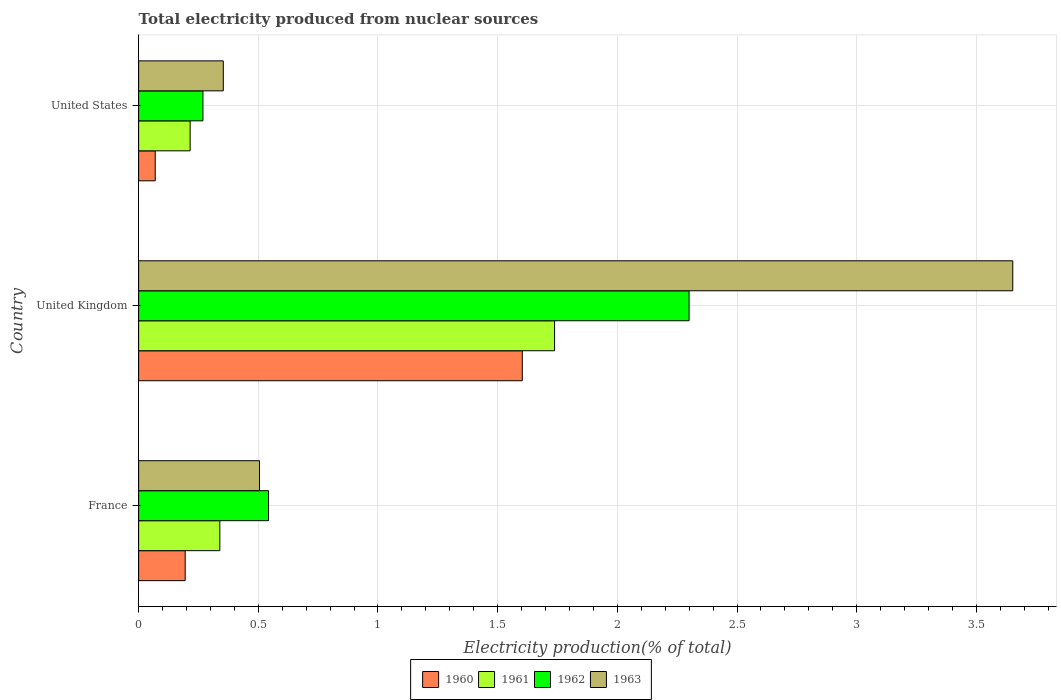How many different coloured bars are there?
Make the answer very short. 4. How many groups of bars are there?
Provide a short and direct response. 3. How many bars are there on the 3rd tick from the top?
Keep it short and to the point. 4. What is the label of the 2nd group of bars from the top?
Provide a succinct answer. United Kingdom. In how many cases, is the number of bars for a given country not equal to the number of legend labels?
Offer a very short reply. 0. What is the total electricity produced in 1962 in United States?
Offer a terse response. 0.27. Across all countries, what is the maximum total electricity produced in 1961?
Provide a short and direct response. 1.74. Across all countries, what is the minimum total electricity produced in 1962?
Your response must be concise. 0.27. What is the total total electricity produced in 1962 in the graph?
Your answer should be compact. 3.11. What is the difference between the total electricity produced in 1963 in France and that in United States?
Offer a terse response. 0.15. What is the difference between the total electricity produced in 1963 in United States and the total electricity produced in 1960 in United Kingdom?
Ensure brevity in your answer.  -1.25. What is the average total electricity produced in 1961 per country?
Keep it short and to the point. 0.76. What is the difference between the total electricity produced in 1962 and total electricity produced in 1960 in United States?
Make the answer very short. 0.2. In how many countries, is the total electricity produced in 1960 greater than 2.2 %?
Your answer should be compact. 0. What is the ratio of the total electricity produced in 1962 in United Kingdom to that in United States?
Your response must be concise. 8.56. Is the difference between the total electricity produced in 1962 in France and United States greater than the difference between the total electricity produced in 1960 in France and United States?
Your response must be concise. Yes. What is the difference between the highest and the second highest total electricity produced in 1962?
Your answer should be very brief. 1.76. What is the difference between the highest and the lowest total electricity produced in 1961?
Keep it short and to the point. 1.52. Is it the case that in every country, the sum of the total electricity produced in 1963 and total electricity produced in 1961 is greater than the sum of total electricity produced in 1960 and total electricity produced in 1962?
Offer a terse response. Yes. What does the 4th bar from the top in France represents?
Your response must be concise. 1960. Is it the case that in every country, the sum of the total electricity produced in 1961 and total electricity produced in 1963 is greater than the total electricity produced in 1960?
Your response must be concise. Yes. How many bars are there?
Offer a very short reply. 12. What is the difference between two consecutive major ticks on the X-axis?
Offer a terse response. 0.5. Does the graph contain any zero values?
Your answer should be compact. No. Does the graph contain grids?
Provide a succinct answer. Yes. How are the legend labels stacked?
Your answer should be compact. Horizontal. What is the title of the graph?
Your response must be concise. Total electricity produced from nuclear sources. Does "2001" appear as one of the legend labels in the graph?
Provide a succinct answer. No. What is the label or title of the X-axis?
Give a very brief answer. Electricity production(% of total). What is the label or title of the Y-axis?
Make the answer very short. Country. What is the Electricity production(% of total) in 1960 in France?
Offer a very short reply. 0.19. What is the Electricity production(% of total) of 1961 in France?
Your response must be concise. 0.34. What is the Electricity production(% of total) in 1962 in France?
Ensure brevity in your answer.  0.54. What is the Electricity production(% of total) in 1963 in France?
Provide a succinct answer. 0.51. What is the Electricity production(% of total) of 1960 in United Kingdom?
Your answer should be compact. 1.6. What is the Electricity production(% of total) of 1961 in United Kingdom?
Give a very brief answer. 1.74. What is the Electricity production(% of total) of 1962 in United Kingdom?
Make the answer very short. 2.3. What is the Electricity production(% of total) of 1963 in United Kingdom?
Give a very brief answer. 3.65. What is the Electricity production(% of total) in 1960 in United States?
Provide a short and direct response. 0.07. What is the Electricity production(% of total) of 1961 in United States?
Offer a terse response. 0.22. What is the Electricity production(% of total) in 1962 in United States?
Offer a very short reply. 0.27. What is the Electricity production(% of total) of 1963 in United States?
Provide a succinct answer. 0.35. Across all countries, what is the maximum Electricity production(% of total) in 1960?
Your answer should be compact. 1.6. Across all countries, what is the maximum Electricity production(% of total) in 1961?
Your response must be concise. 1.74. Across all countries, what is the maximum Electricity production(% of total) in 1962?
Ensure brevity in your answer.  2.3. Across all countries, what is the maximum Electricity production(% of total) of 1963?
Give a very brief answer. 3.65. Across all countries, what is the minimum Electricity production(% of total) of 1960?
Provide a succinct answer. 0.07. Across all countries, what is the minimum Electricity production(% of total) in 1961?
Make the answer very short. 0.22. Across all countries, what is the minimum Electricity production(% of total) in 1962?
Offer a terse response. 0.27. Across all countries, what is the minimum Electricity production(% of total) in 1963?
Keep it short and to the point. 0.35. What is the total Electricity production(% of total) of 1960 in the graph?
Provide a short and direct response. 1.87. What is the total Electricity production(% of total) of 1961 in the graph?
Provide a short and direct response. 2.29. What is the total Electricity production(% of total) in 1962 in the graph?
Make the answer very short. 3.11. What is the total Electricity production(% of total) of 1963 in the graph?
Provide a succinct answer. 4.51. What is the difference between the Electricity production(% of total) in 1960 in France and that in United Kingdom?
Your response must be concise. -1.41. What is the difference between the Electricity production(% of total) in 1961 in France and that in United Kingdom?
Give a very brief answer. -1.4. What is the difference between the Electricity production(% of total) in 1962 in France and that in United Kingdom?
Keep it short and to the point. -1.76. What is the difference between the Electricity production(% of total) of 1963 in France and that in United Kingdom?
Offer a very short reply. -3.15. What is the difference between the Electricity production(% of total) in 1960 in France and that in United States?
Make the answer very short. 0.13. What is the difference between the Electricity production(% of total) in 1961 in France and that in United States?
Your response must be concise. 0.12. What is the difference between the Electricity production(% of total) of 1962 in France and that in United States?
Your answer should be very brief. 0.27. What is the difference between the Electricity production(% of total) of 1963 in France and that in United States?
Offer a terse response. 0.15. What is the difference between the Electricity production(% of total) of 1960 in United Kingdom and that in United States?
Offer a very short reply. 1.53. What is the difference between the Electricity production(% of total) in 1961 in United Kingdom and that in United States?
Your response must be concise. 1.52. What is the difference between the Electricity production(% of total) in 1962 in United Kingdom and that in United States?
Provide a succinct answer. 2.03. What is the difference between the Electricity production(% of total) of 1963 in United Kingdom and that in United States?
Make the answer very short. 3.3. What is the difference between the Electricity production(% of total) of 1960 in France and the Electricity production(% of total) of 1961 in United Kingdom?
Your answer should be very brief. -1.54. What is the difference between the Electricity production(% of total) of 1960 in France and the Electricity production(% of total) of 1962 in United Kingdom?
Provide a short and direct response. -2.11. What is the difference between the Electricity production(% of total) of 1960 in France and the Electricity production(% of total) of 1963 in United Kingdom?
Provide a short and direct response. -3.46. What is the difference between the Electricity production(% of total) of 1961 in France and the Electricity production(% of total) of 1962 in United Kingdom?
Offer a terse response. -1.96. What is the difference between the Electricity production(% of total) of 1961 in France and the Electricity production(% of total) of 1963 in United Kingdom?
Make the answer very short. -3.31. What is the difference between the Electricity production(% of total) of 1962 in France and the Electricity production(% of total) of 1963 in United Kingdom?
Provide a succinct answer. -3.11. What is the difference between the Electricity production(% of total) in 1960 in France and the Electricity production(% of total) in 1961 in United States?
Your answer should be compact. -0.02. What is the difference between the Electricity production(% of total) of 1960 in France and the Electricity production(% of total) of 1962 in United States?
Provide a short and direct response. -0.07. What is the difference between the Electricity production(% of total) in 1960 in France and the Electricity production(% of total) in 1963 in United States?
Offer a terse response. -0.16. What is the difference between the Electricity production(% of total) of 1961 in France and the Electricity production(% of total) of 1962 in United States?
Your answer should be compact. 0.07. What is the difference between the Electricity production(% of total) of 1961 in France and the Electricity production(% of total) of 1963 in United States?
Offer a terse response. -0.01. What is the difference between the Electricity production(% of total) in 1962 in France and the Electricity production(% of total) in 1963 in United States?
Offer a very short reply. 0.19. What is the difference between the Electricity production(% of total) in 1960 in United Kingdom and the Electricity production(% of total) in 1961 in United States?
Provide a short and direct response. 1.39. What is the difference between the Electricity production(% of total) of 1960 in United Kingdom and the Electricity production(% of total) of 1962 in United States?
Offer a terse response. 1.33. What is the difference between the Electricity production(% of total) in 1960 in United Kingdom and the Electricity production(% of total) in 1963 in United States?
Your answer should be very brief. 1.25. What is the difference between the Electricity production(% of total) in 1961 in United Kingdom and the Electricity production(% of total) in 1962 in United States?
Your response must be concise. 1.47. What is the difference between the Electricity production(% of total) in 1961 in United Kingdom and the Electricity production(% of total) in 1963 in United States?
Offer a very short reply. 1.38. What is the difference between the Electricity production(% of total) of 1962 in United Kingdom and the Electricity production(% of total) of 1963 in United States?
Provide a short and direct response. 1.95. What is the average Electricity production(% of total) of 1960 per country?
Offer a very short reply. 0.62. What is the average Electricity production(% of total) in 1961 per country?
Make the answer very short. 0.76. What is the average Electricity production(% of total) in 1963 per country?
Your answer should be compact. 1.5. What is the difference between the Electricity production(% of total) in 1960 and Electricity production(% of total) in 1961 in France?
Make the answer very short. -0.14. What is the difference between the Electricity production(% of total) of 1960 and Electricity production(% of total) of 1962 in France?
Provide a short and direct response. -0.35. What is the difference between the Electricity production(% of total) in 1960 and Electricity production(% of total) in 1963 in France?
Your answer should be very brief. -0.31. What is the difference between the Electricity production(% of total) of 1961 and Electricity production(% of total) of 1962 in France?
Your answer should be very brief. -0.2. What is the difference between the Electricity production(% of total) in 1961 and Electricity production(% of total) in 1963 in France?
Give a very brief answer. -0.17. What is the difference between the Electricity production(% of total) of 1962 and Electricity production(% of total) of 1963 in France?
Keep it short and to the point. 0.04. What is the difference between the Electricity production(% of total) in 1960 and Electricity production(% of total) in 1961 in United Kingdom?
Offer a very short reply. -0.13. What is the difference between the Electricity production(% of total) of 1960 and Electricity production(% of total) of 1962 in United Kingdom?
Your answer should be very brief. -0.7. What is the difference between the Electricity production(% of total) in 1960 and Electricity production(% of total) in 1963 in United Kingdom?
Keep it short and to the point. -2.05. What is the difference between the Electricity production(% of total) of 1961 and Electricity production(% of total) of 1962 in United Kingdom?
Make the answer very short. -0.56. What is the difference between the Electricity production(% of total) in 1961 and Electricity production(% of total) in 1963 in United Kingdom?
Ensure brevity in your answer.  -1.91. What is the difference between the Electricity production(% of total) of 1962 and Electricity production(% of total) of 1963 in United Kingdom?
Your answer should be compact. -1.35. What is the difference between the Electricity production(% of total) in 1960 and Electricity production(% of total) in 1961 in United States?
Your answer should be very brief. -0.15. What is the difference between the Electricity production(% of total) in 1960 and Electricity production(% of total) in 1962 in United States?
Provide a succinct answer. -0.2. What is the difference between the Electricity production(% of total) in 1960 and Electricity production(% of total) in 1963 in United States?
Offer a very short reply. -0.28. What is the difference between the Electricity production(% of total) of 1961 and Electricity production(% of total) of 1962 in United States?
Your answer should be very brief. -0.05. What is the difference between the Electricity production(% of total) of 1961 and Electricity production(% of total) of 1963 in United States?
Ensure brevity in your answer.  -0.14. What is the difference between the Electricity production(% of total) of 1962 and Electricity production(% of total) of 1963 in United States?
Give a very brief answer. -0.09. What is the ratio of the Electricity production(% of total) of 1960 in France to that in United Kingdom?
Provide a short and direct response. 0.12. What is the ratio of the Electricity production(% of total) in 1961 in France to that in United Kingdom?
Provide a short and direct response. 0.2. What is the ratio of the Electricity production(% of total) of 1962 in France to that in United Kingdom?
Provide a short and direct response. 0.24. What is the ratio of the Electricity production(% of total) of 1963 in France to that in United Kingdom?
Ensure brevity in your answer.  0.14. What is the ratio of the Electricity production(% of total) in 1960 in France to that in United States?
Your answer should be compact. 2.81. What is the ratio of the Electricity production(% of total) of 1961 in France to that in United States?
Provide a short and direct response. 1.58. What is the ratio of the Electricity production(% of total) of 1962 in France to that in United States?
Your response must be concise. 2.02. What is the ratio of the Electricity production(% of total) in 1963 in France to that in United States?
Ensure brevity in your answer.  1.43. What is the ratio of the Electricity production(% of total) in 1960 in United Kingdom to that in United States?
Your answer should be compact. 23.14. What is the ratio of the Electricity production(% of total) in 1961 in United Kingdom to that in United States?
Give a very brief answer. 8.08. What is the ratio of the Electricity production(% of total) in 1962 in United Kingdom to that in United States?
Provide a succinct answer. 8.56. What is the ratio of the Electricity production(% of total) of 1963 in United Kingdom to that in United States?
Give a very brief answer. 10.32. What is the difference between the highest and the second highest Electricity production(% of total) of 1960?
Give a very brief answer. 1.41. What is the difference between the highest and the second highest Electricity production(% of total) of 1961?
Provide a succinct answer. 1.4. What is the difference between the highest and the second highest Electricity production(% of total) in 1962?
Provide a short and direct response. 1.76. What is the difference between the highest and the second highest Electricity production(% of total) of 1963?
Offer a very short reply. 3.15. What is the difference between the highest and the lowest Electricity production(% of total) of 1960?
Keep it short and to the point. 1.53. What is the difference between the highest and the lowest Electricity production(% of total) in 1961?
Keep it short and to the point. 1.52. What is the difference between the highest and the lowest Electricity production(% of total) of 1962?
Keep it short and to the point. 2.03. What is the difference between the highest and the lowest Electricity production(% of total) in 1963?
Your answer should be very brief. 3.3. 